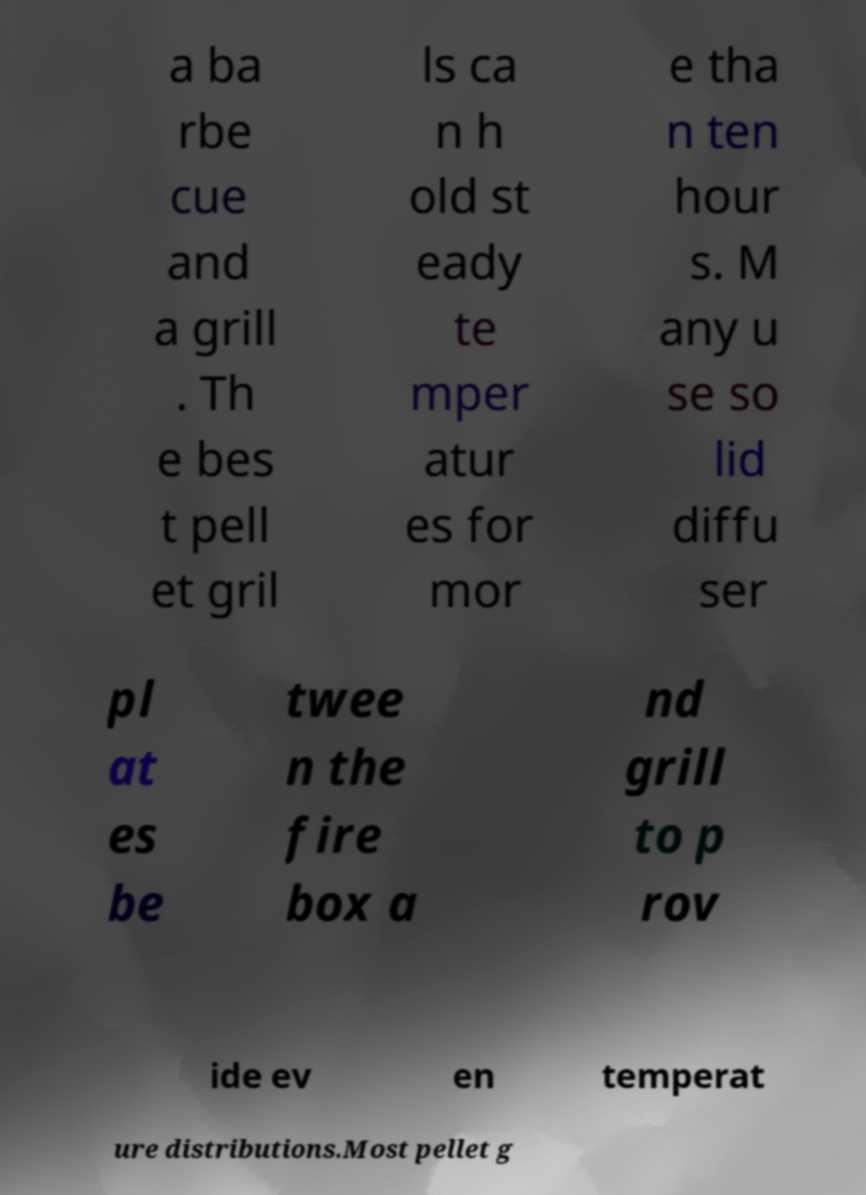What messages or text are displayed in this image? I need them in a readable, typed format. a ba rbe cue and a grill . Th e bes t pell et gril ls ca n h old st eady te mper atur es for mor e tha n ten hour s. M any u se so lid diffu ser pl at es be twee n the fire box a nd grill to p rov ide ev en temperat ure distributions.Most pellet g 